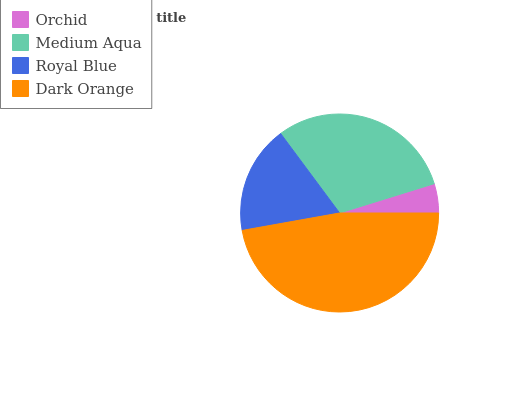Is Orchid the minimum?
Answer yes or no. Yes. Is Dark Orange the maximum?
Answer yes or no. Yes. Is Medium Aqua the minimum?
Answer yes or no. No. Is Medium Aqua the maximum?
Answer yes or no. No. Is Medium Aqua greater than Orchid?
Answer yes or no. Yes. Is Orchid less than Medium Aqua?
Answer yes or no. Yes. Is Orchid greater than Medium Aqua?
Answer yes or no. No. Is Medium Aqua less than Orchid?
Answer yes or no. No. Is Medium Aqua the high median?
Answer yes or no. Yes. Is Royal Blue the low median?
Answer yes or no. Yes. Is Dark Orange the high median?
Answer yes or no. No. Is Orchid the low median?
Answer yes or no. No. 